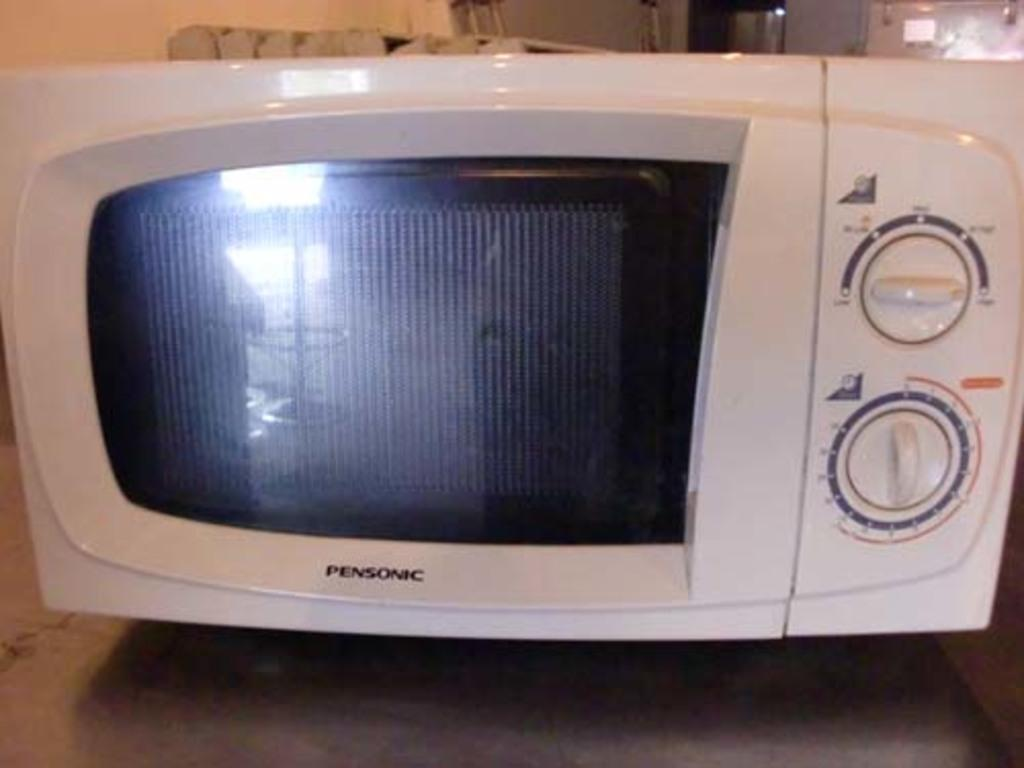<image>
Share a concise interpretation of the image provided. A Pensonic microwave with manual dials instead of buttons. 